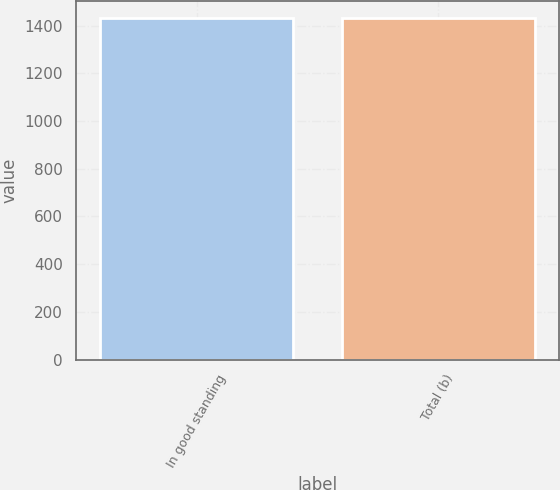Convert chart. <chart><loc_0><loc_0><loc_500><loc_500><bar_chart><fcel>In good standing<fcel>Total (b)<nl><fcel>1431<fcel>1431.1<nl></chart> 